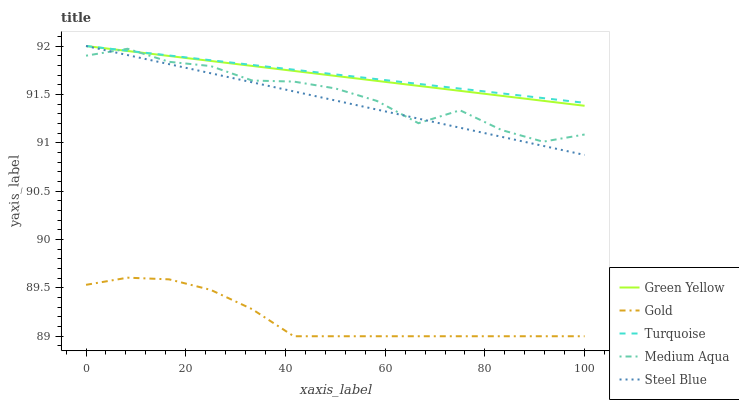Does Gold have the minimum area under the curve?
Answer yes or no. Yes. Does Turquoise have the maximum area under the curve?
Answer yes or no. Yes. Does Green Yellow have the minimum area under the curve?
Answer yes or no. No. Does Green Yellow have the maximum area under the curve?
Answer yes or no. No. Is Steel Blue the smoothest?
Answer yes or no. Yes. Is Medium Aqua the roughest?
Answer yes or no. Yes. Is Green Yellow the smoothest?
Answer yes or no. No. Is Green Yellow the roughest?
Answer yes or no. No. Does Gold have the lowest value?
Answer yes or no. Yes. Does Green Yellow have the lowest value?
Answer yes or no. No. Does Steel Blue have the highest value?
Answer yes or no. Yes. Does Medium Aqua have the highest value?
Answer yes or no. No. Is Gold less than Turquoise?
Answer yes or no. Yes. Is Medium Aqua greater than Gold?
Answer yes or no. Yes. Does Medium Aqua intersect Turquoise?
Answer yes or no. Yes. Is Medium Aqua less than Turquoise?
Answer yes or no. No. Is Medium Aqua greater than Turquoise?
Answer yes or no. No. Does Gold intersect Turquoise?
Answer yes or no. No. 